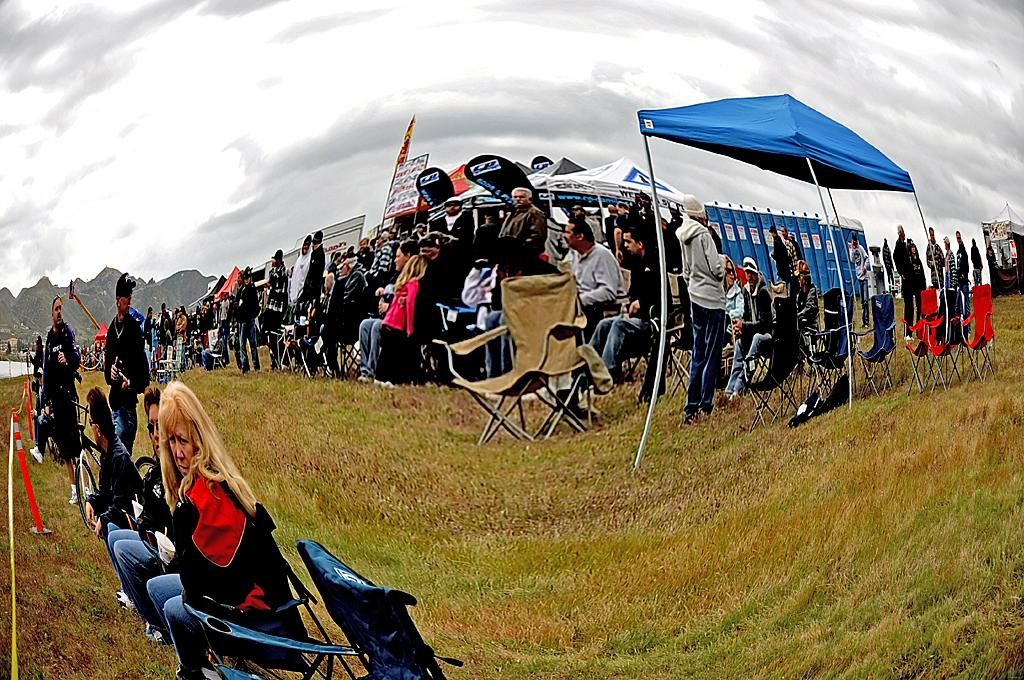How many people can be seen in the image? There are many people in the image. What structure is present in the image? There is a tent in the image. What type of seating is available in the image? There are chairs in the image. What type of terrain is visible in the image? There is grass in the image. What natural feature can be seen in the background of the image? There are mountains in the image. What is visible above the people and structures in the image? There is a sky visible in the image. What type of wool is being spun by the people in the image? There is no wool or spinning activity present in the image. What type of pet can be seen interacting with the people in the image? There are no pets visible in the image. 